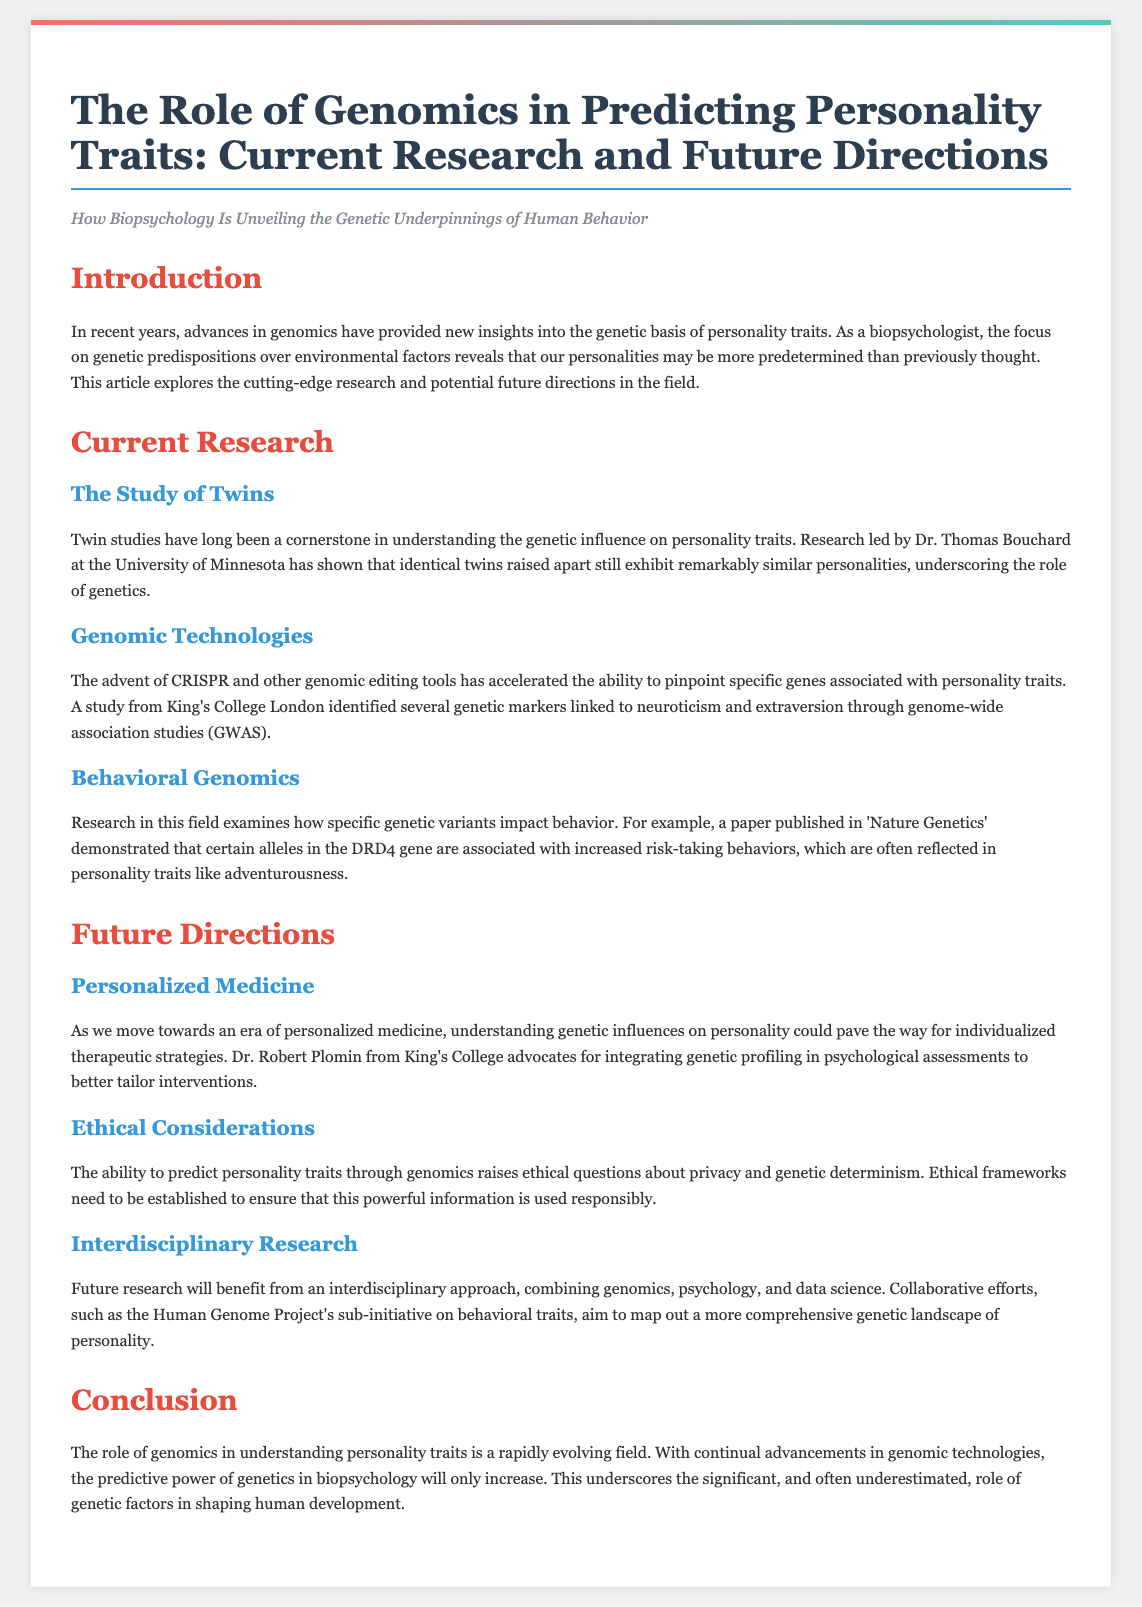What is the title of the article? The title is explicitly stated in the document, which is "The Role of Genomics in Predicting Personality Traits: Current Research and Future Directions."
Answer: The Role of Genomics in Predicting Personality Traits: Current Research and Future Directions Who conducted research on twins at the University of Minnesota? The document mentions Dr. Thomas Bouchard as the researcher involved in twin studies at the University of Minnesota.
Answer: Dr. Thomas Bouchard What technology has accelerated the ability to pinpoint specific genes? The document states that the advent of CRISPR and other genomic editing tools have accelerated this process.
Answer: CRISPR What is associated with increased risk-taking behaviors according to the Nature Genetics paper? The document refers to certain alleles in the DRD4 gene being linked to increased risk-taking behaviors.
Answer: DRD4 gene Who advocates for integrating genetic profiling in psychological assessments? Dr. Robert Plomin from King's College is noted in the document as advocating for this integration.
Answer: Dr. Robert Plomin What raises ethical questions about privacy and genetic determinism? The document indicates that the ability to predict personality traits through genomics raises these ethical questions.
Answer: Predicting personality traits What interdisciplinary approach is suggested for future research? The document suggests that combining genomics, psychology, and data science is beneficial for future research efforts.
Answer: Combining genomics, psychology, and data science What is the focus of the article? The document primarily focuses on the genetic basis of personality traits within the realm of biopsychology.
Answer: Genetic basis of personality traits What did the study from King's College London identify? The study identified several genetic markers linked to neuroticism and extraversion through genome-wide association studies.
Answer: Genetic markers linked to neuroticism and extraversion 